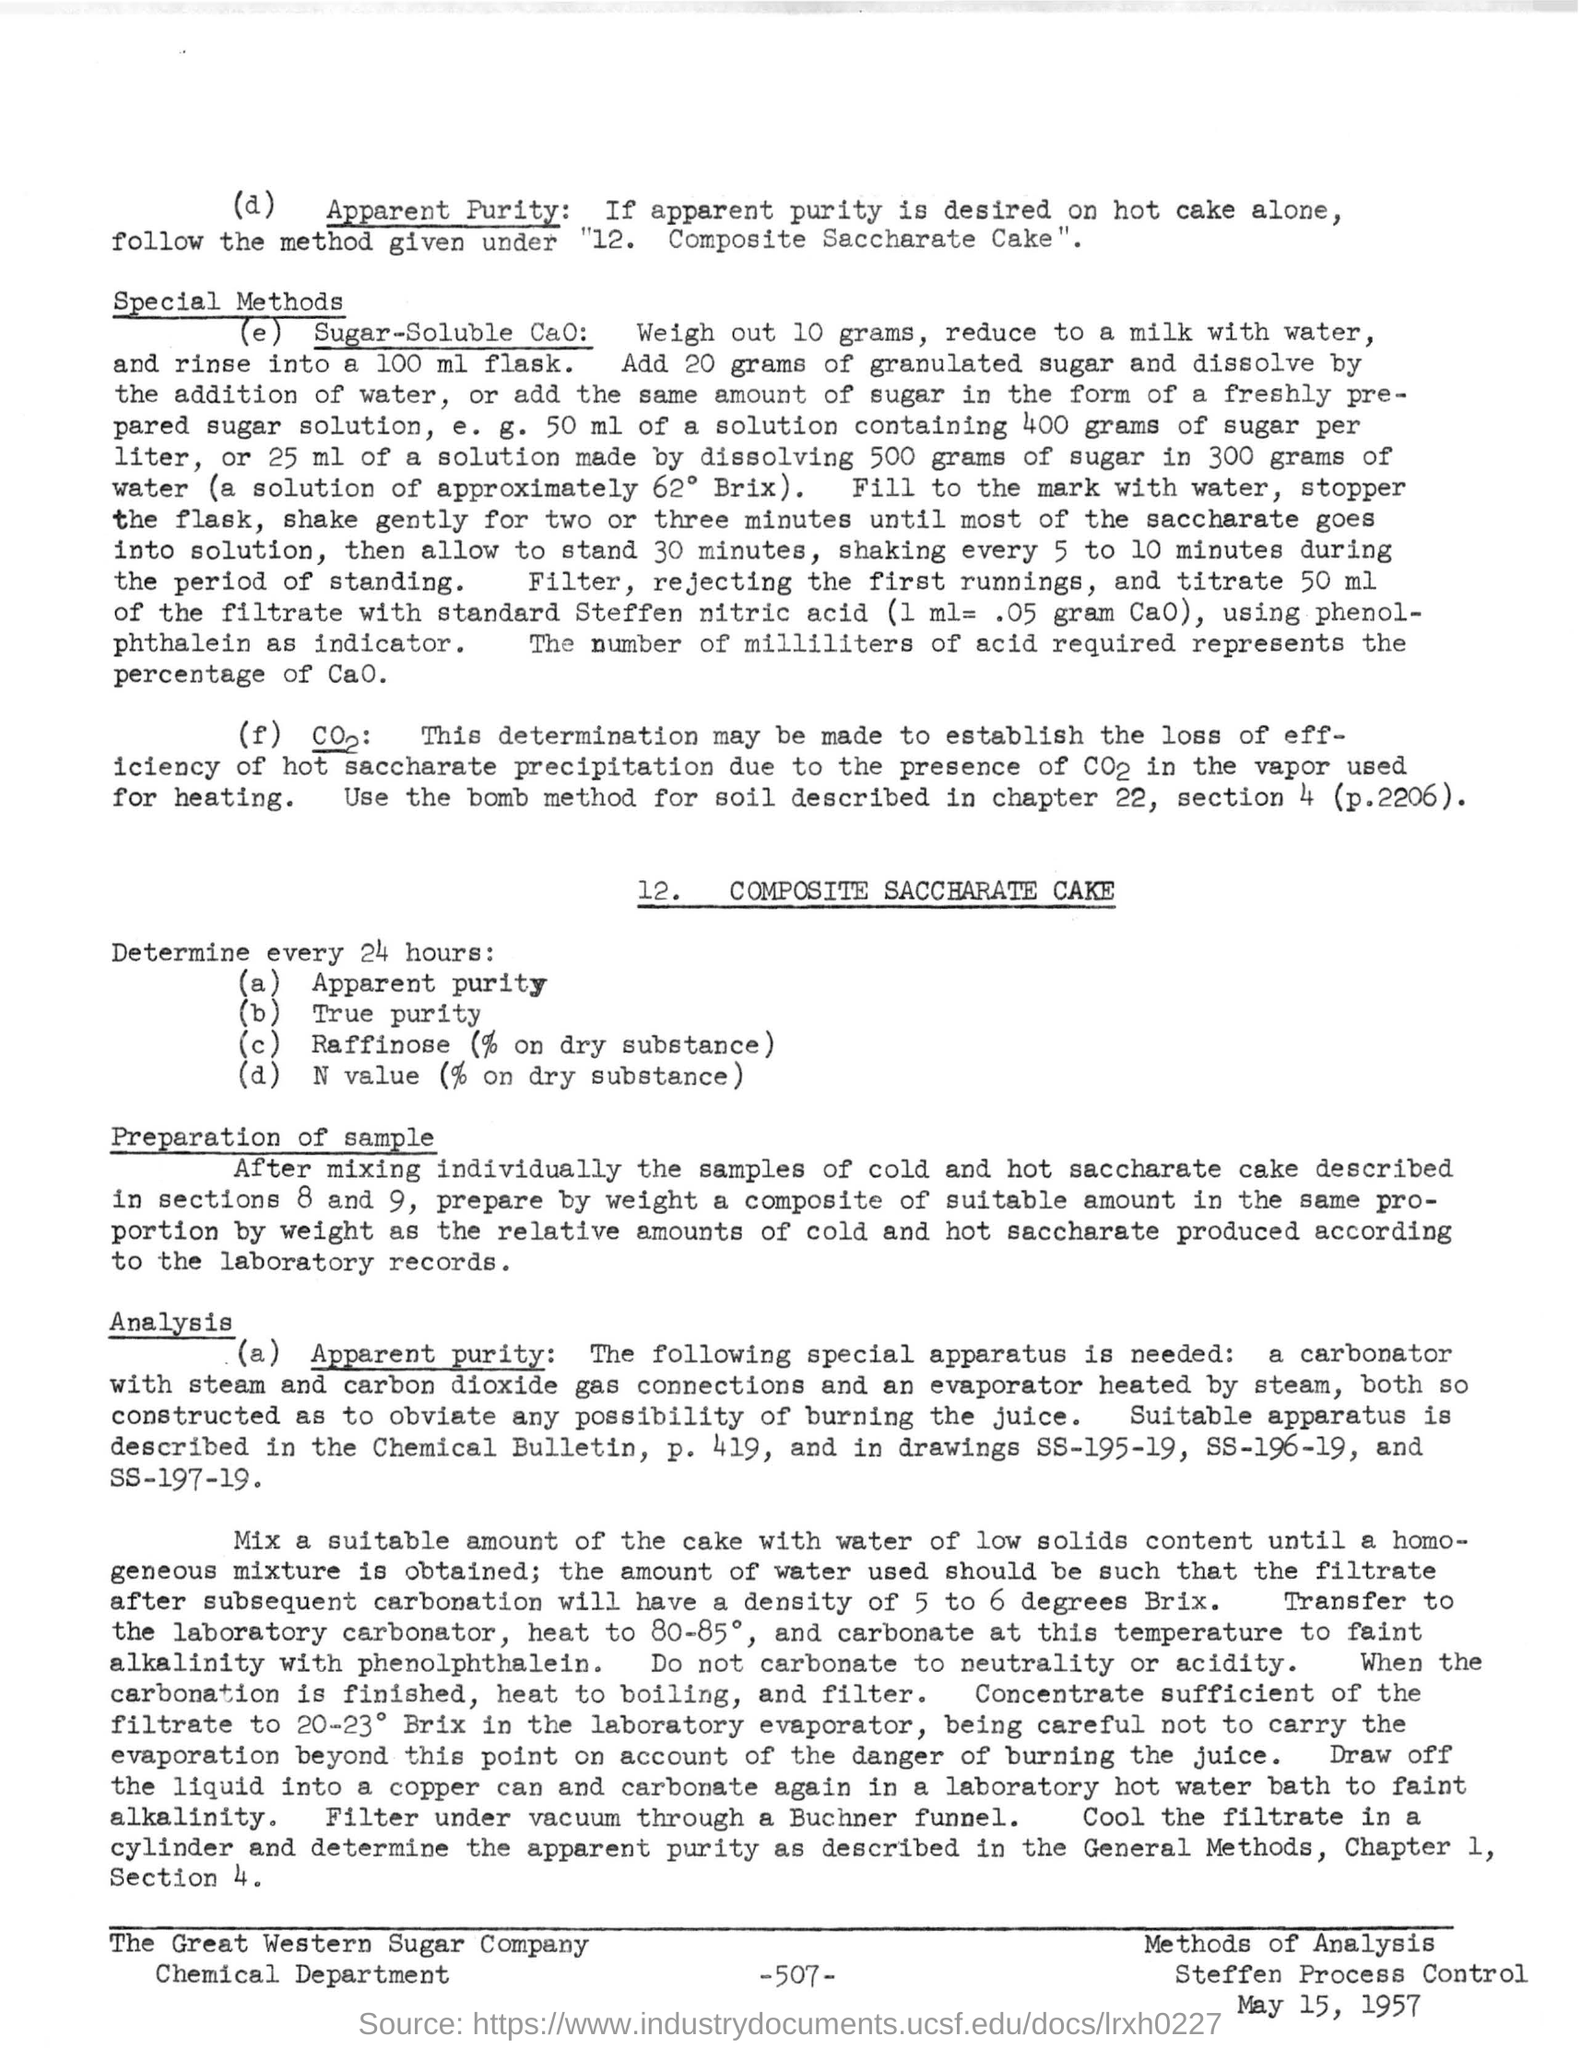Indicate a few pertinent items in this graphic. The number written in the bottom of the document is -507-. The date mentioned at the bottom of the document is May 15, 1957. 